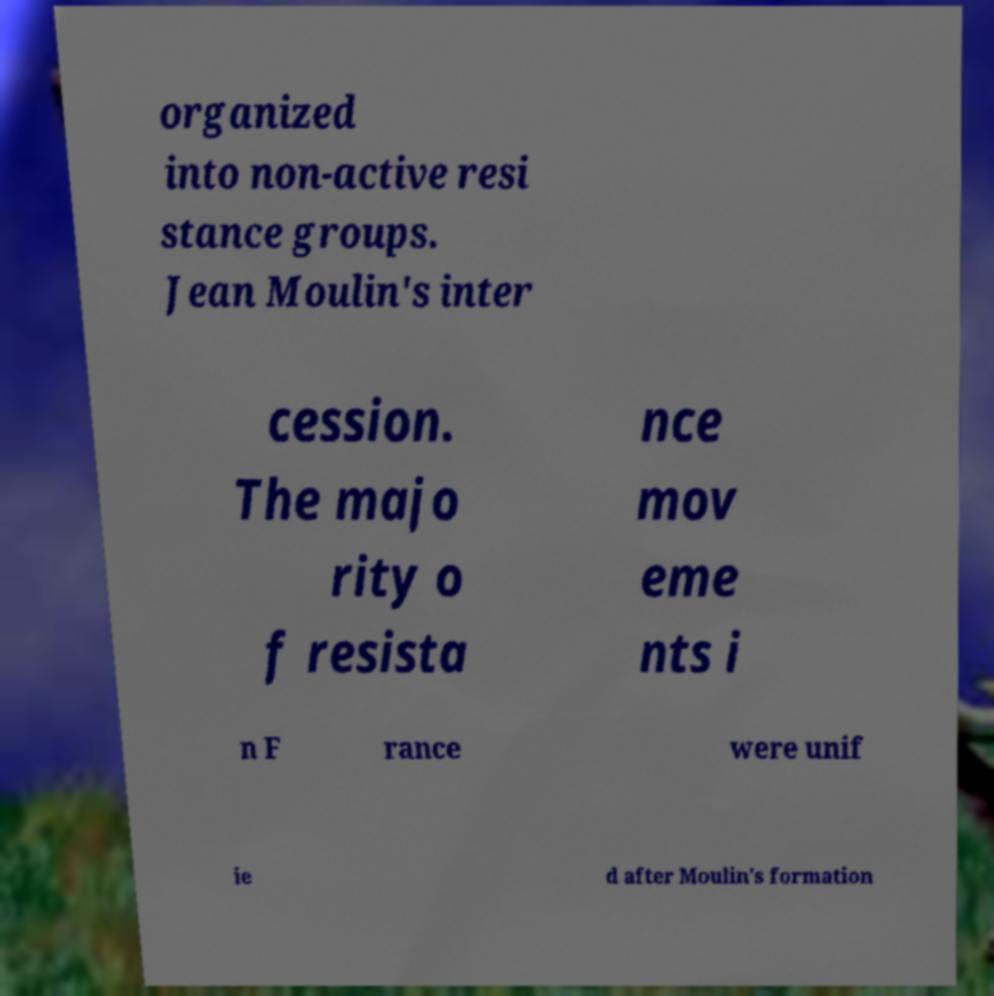I need the written content from this picture converted into text. Can you do that? organized into non-active resi stance groups. Jean Moulin's inter cession. The majo rity o f resista nce mov eme nts i n F rance were unif ie d after Moulin's formation 